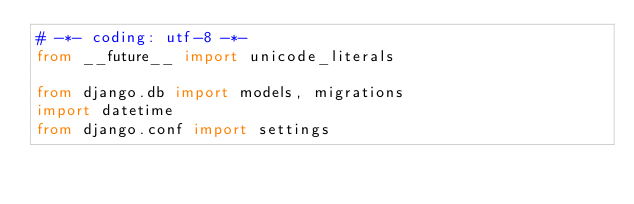Convert code to text. <code><loc_0><loc_0><loc_500><loc_500><_Python_># -*- coding: utf-8 -*-
from __future__ import unicode_literals

from django.db import models, migrations
import datetime
from django.conf import settings

</code> 